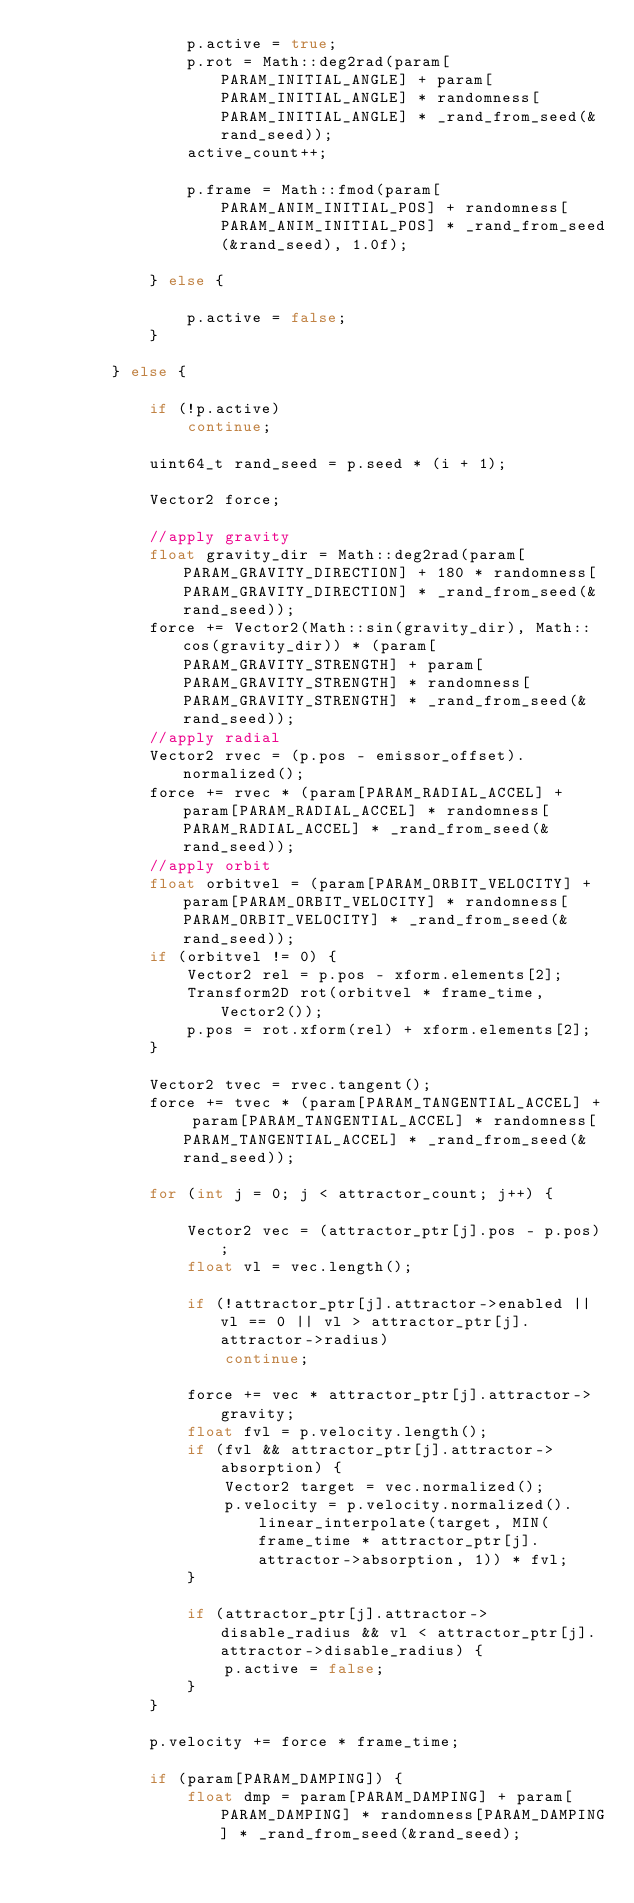<code> <loc_0><loc_0><loc_500><loc_500><_C++_>				p.active = true;
				p.rot = Math::deg2rad(param[PARAM_INITIAL_ANGLE] + param[PARAM_INITIAL_ANGLE] * randomness[PARAM_INITIAL_ANGLE] * _rand_from_seed(&rand_seed));
				active_count++;

				p.frame = Math::fmod(param[PARAM_ANIM_INITIAL_POS] + randomness[PARAM_ANIM_INITIAL_POS] * _rand_from_seed(&rand_seed), 1.0f);

			} else {

				p.active = false;
			}

		} else {

			if (!p.active)
				continue;

			uint64_t rand_seed = p.seed * (i + 1);

			Vector2 force;

			//apply gravity
			float gravity_dir = Math::deg2rad(param[PARAM_GRAVITY_DIRECTION] + 180 * randomness[PARAM_GRAVITY_DIRECTION] * _rand_from_seed(&rand_seed));
			force += Vector2(Math::sin(gravity_dir), Math::cos(gravity_dir)) * (param[PARAM_GRAVITY_STRENGTH] + param[PARAM_GRAVITY_STRENGTH] * randomness[PARAM_GRAVITY_STRENGTH] * _rand_from_seed(&rand_seed));
			//apply radial
			Vector2 rvec = (p.pos - emissor_offset).normalized();
			force += rvec * (param[PARAM_RADIAL_ACCEL] + param[PARAM_RADIAL_ACCEL] * randomness[PARAM_RADIAL_ACCEL] * _rand_from_seed(&rand_seed));
			//apply orbit
			float orbitvel = (param[PARAM_ORBIT_VELOCITY] + param[PARAM_ORBIT_VELOCITY] * randomness[PARAM_ORBIT_VELOCITY] * _rand_from_seed(&rand_seed));
			if (orbitvel != 0) {
				Vector2 rel = p.pos - xform.elements[2];
				Transform2D rot(orbitvel * frame_time, Vector2());
				p.pos = rot.xform(rel) + xform.elements[2];
			}

			Vector2 tvec = rvec.tangent();
			force += tvec * (param[PARAM_TANGENTIAL_ACCEL] + param[PARAM_TANGENTIAL_ACCEL] * randomness[PARAM_TANGENTIAL_ACCEL] * _rand_from_seed(&rand_seed));

			for (int j = 0; j < attractor_count; j++) {

				Vector2 vec = (attractor_ptr[j].pos - p.pos);
				float vl = vec.length();

				if (!attractor_ptr[j].attractor->enabled || vl == 0 || vl > attractor_ptr[j].attractor->radius)
					continue;

				force += vec * attractor_ptr[j].attractor->gravity;
				float fvl = p.velocity.length();
				if (fvl && attractor_ptr[j].attractor->absorption) {
					Vector2 target = vec.normalized();
					p.velocity = p.velocity.normalized().linear_interpolate(target, MIN(frame_time * attractor_ptr[j].attractor->absorption, 1)) * fvl;
				}

				if (attractor_ptr[j].attractor->disable_radius && vl < attractor_ptr[j].attractor->disable_radius) {
					p.active = false;
				}
			}

			p.velocity += force * frame_time;

			if (param[PARAM_DAMPING]) {
				float dmp = param[PARAM_DAMPING] + param[PARAM_DAMPING] * randomness[PARAM_DAMPING] * _rand_from_seed(&rand_seed);</code> 